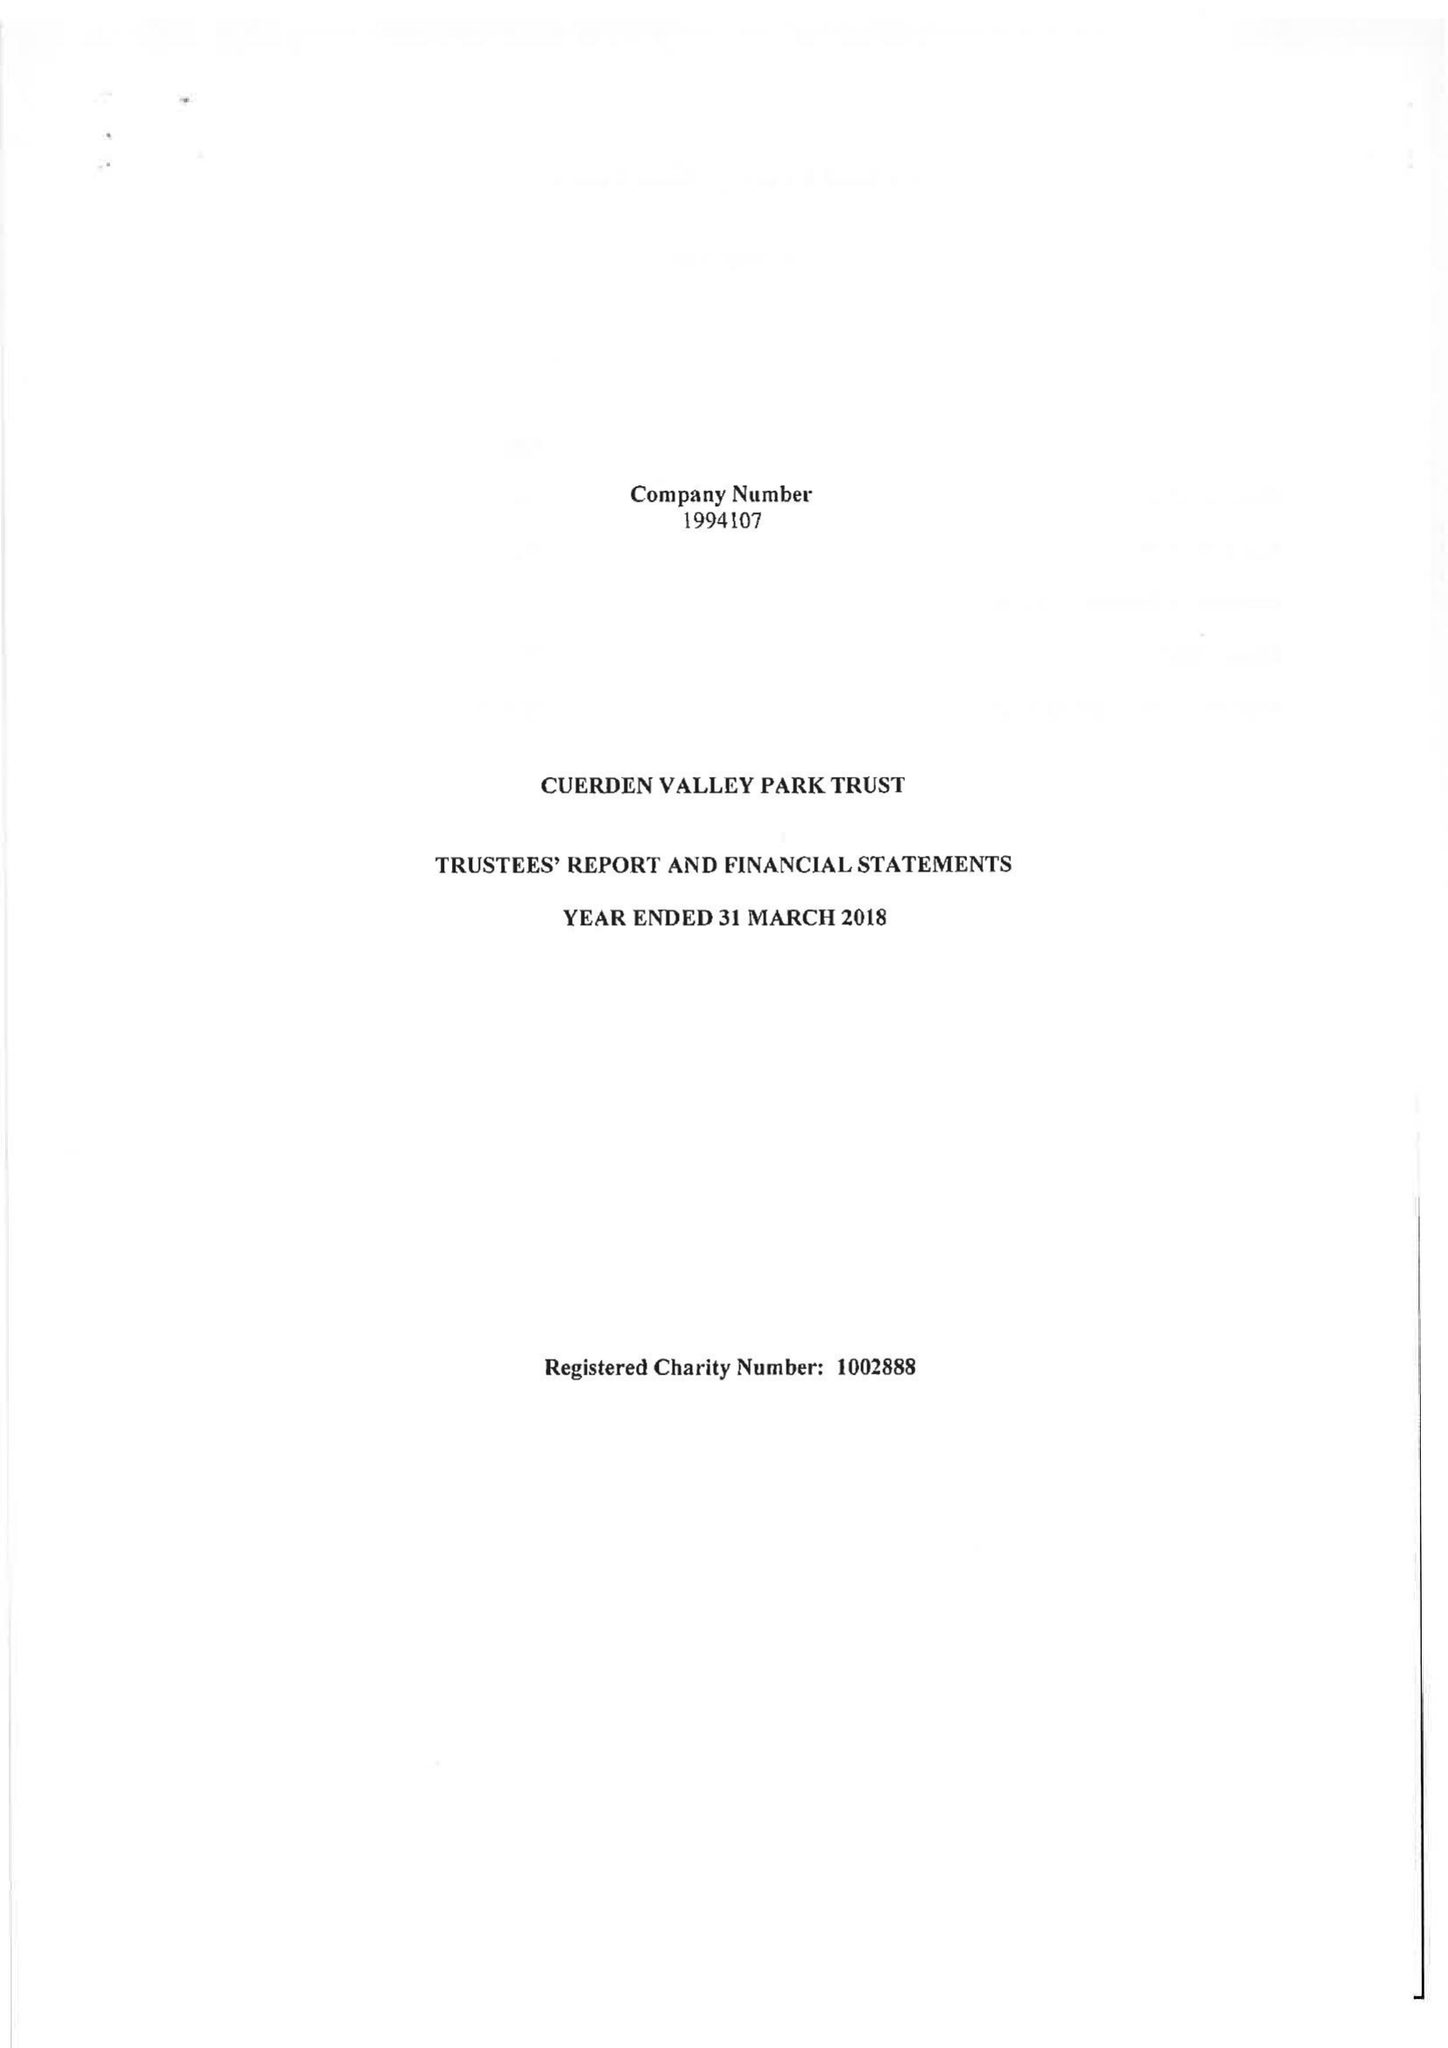What is the value for the charity_name?
Answer the question using a single word or phrase. Cuerden Valley Park Trust 